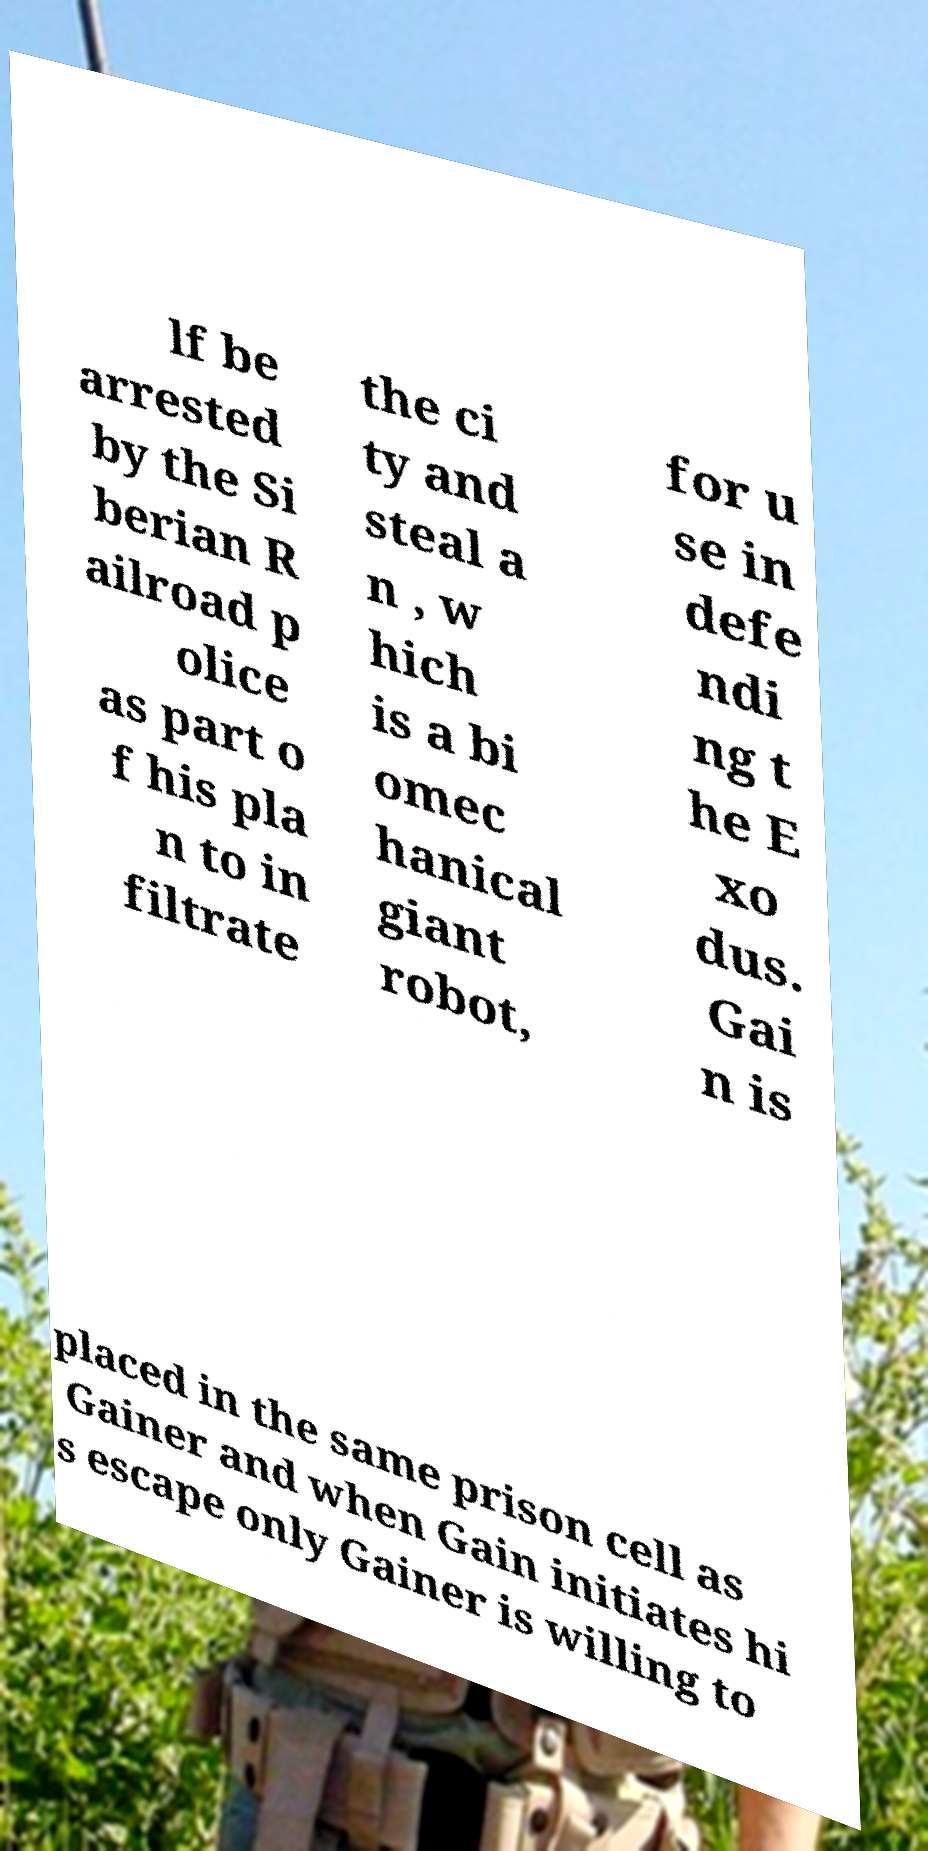I need the written content from this picture converted into text. Can you do that? lf be arrested by the Si berian R ailroad p olice as part o f his pla n to in filtrate the ci ty and steal a n , w hich is a bi omec hanical giant robot, for u se in defe ndi ng t he E xo dus. Gai n is placed in the same prison cell as Gainer and when Gain initiates hi s escape only Gainer is willing to 